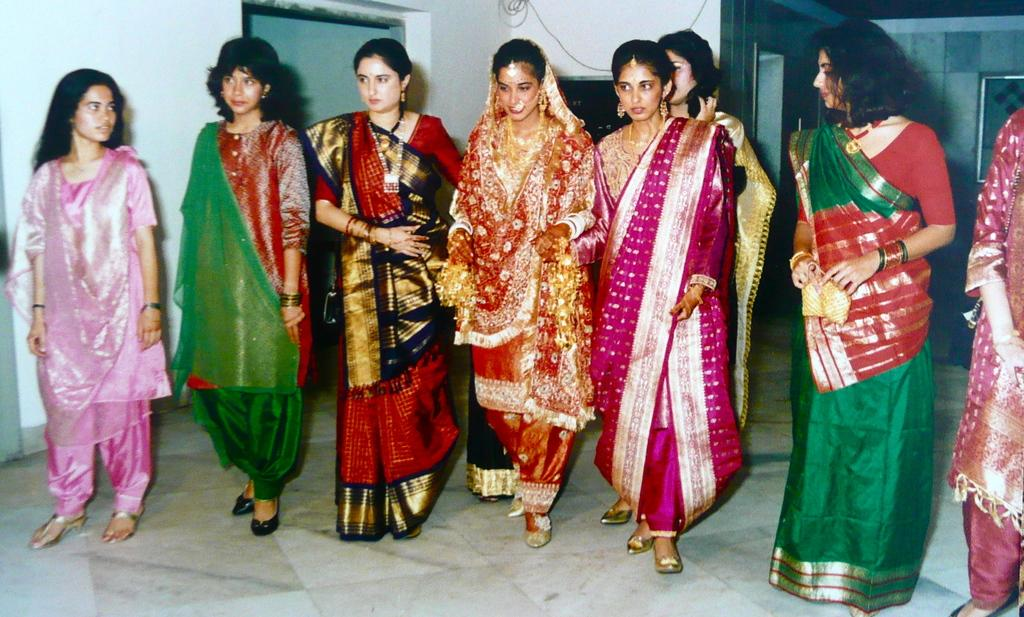How many women are in the foreground of the image? There are eight women in the foreground of the image. What are the women standing on? The women are standing on the floor. What type of clothing are the women wearing? The women are wearing ethnic wear. What can be seen in the background of the image? There is a wall, an entrance, and a frame on the wall in the background of the image. What type of cabbage is used in the design of the women's clothing? There is no cabbage used in the design of the women's clothing; they are wearing ethnic wear. What experience can be gained from observing the frame on the wall in the background of the image? There is no experience to be gained from observing the frame on the wall in the background of the image; it is simply a decorative element. 